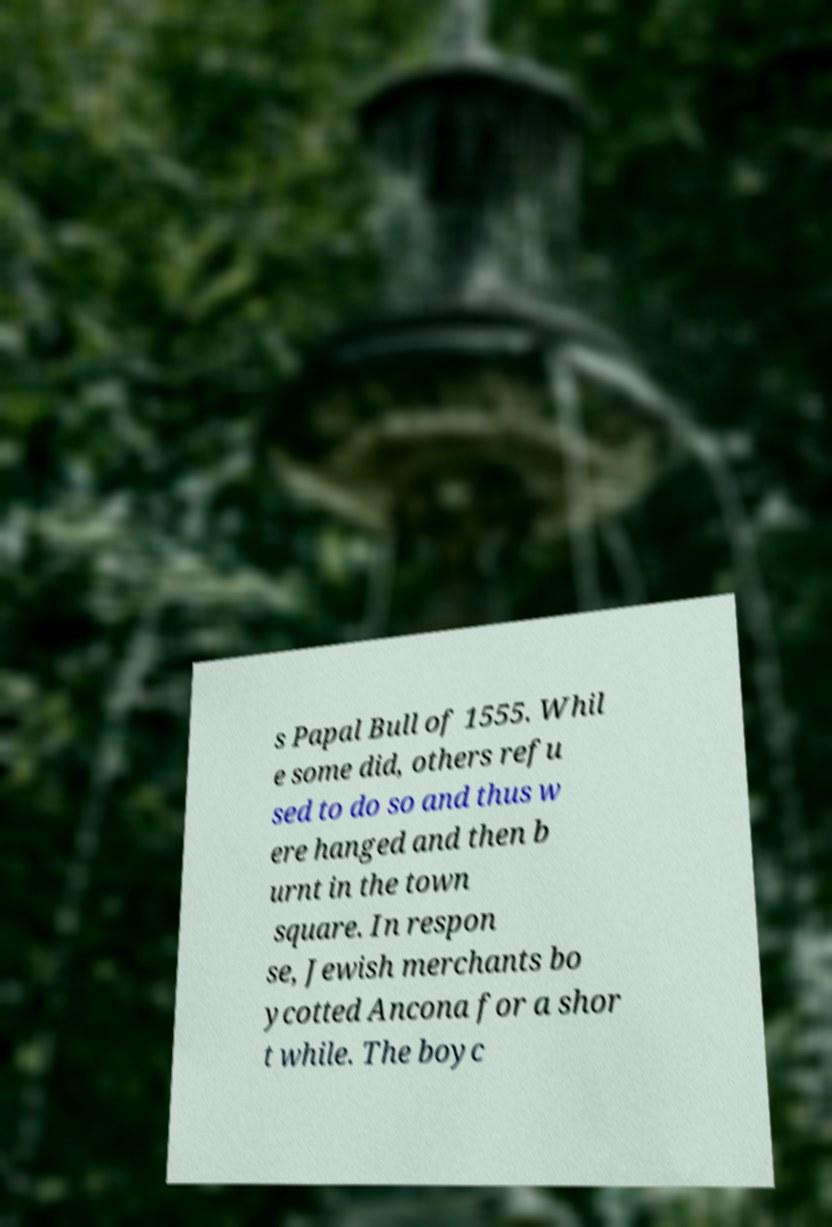Please read and relay the text visible in this image. What does it say? s Papal Bull of 1555. Whil e some did, others refu sed to do so and thus w ere hanged and then b urnt in the town square. In respon se, Jewish merchants bo ycotted Ancona for a shor t while. The boyc 